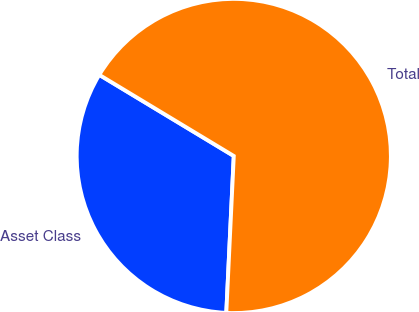<chart> <loc_0><loc_0><loc_500><loc_500><pie_chart><fcel>Asset Class<fcel>Total<nl><fcel>32.88%<fcel>67.12%<nl></chart> 